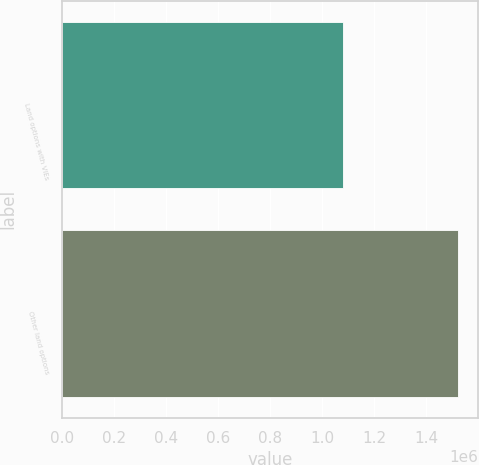Convert chart. <chart><loc_0><loc_0><loc_500><loc_500><bar_chart><fcel>Land options with VIEs<fcel>Other land options<nl><fcel>1.07951e+06<fcel>1.5229e+06<nl></chart> 